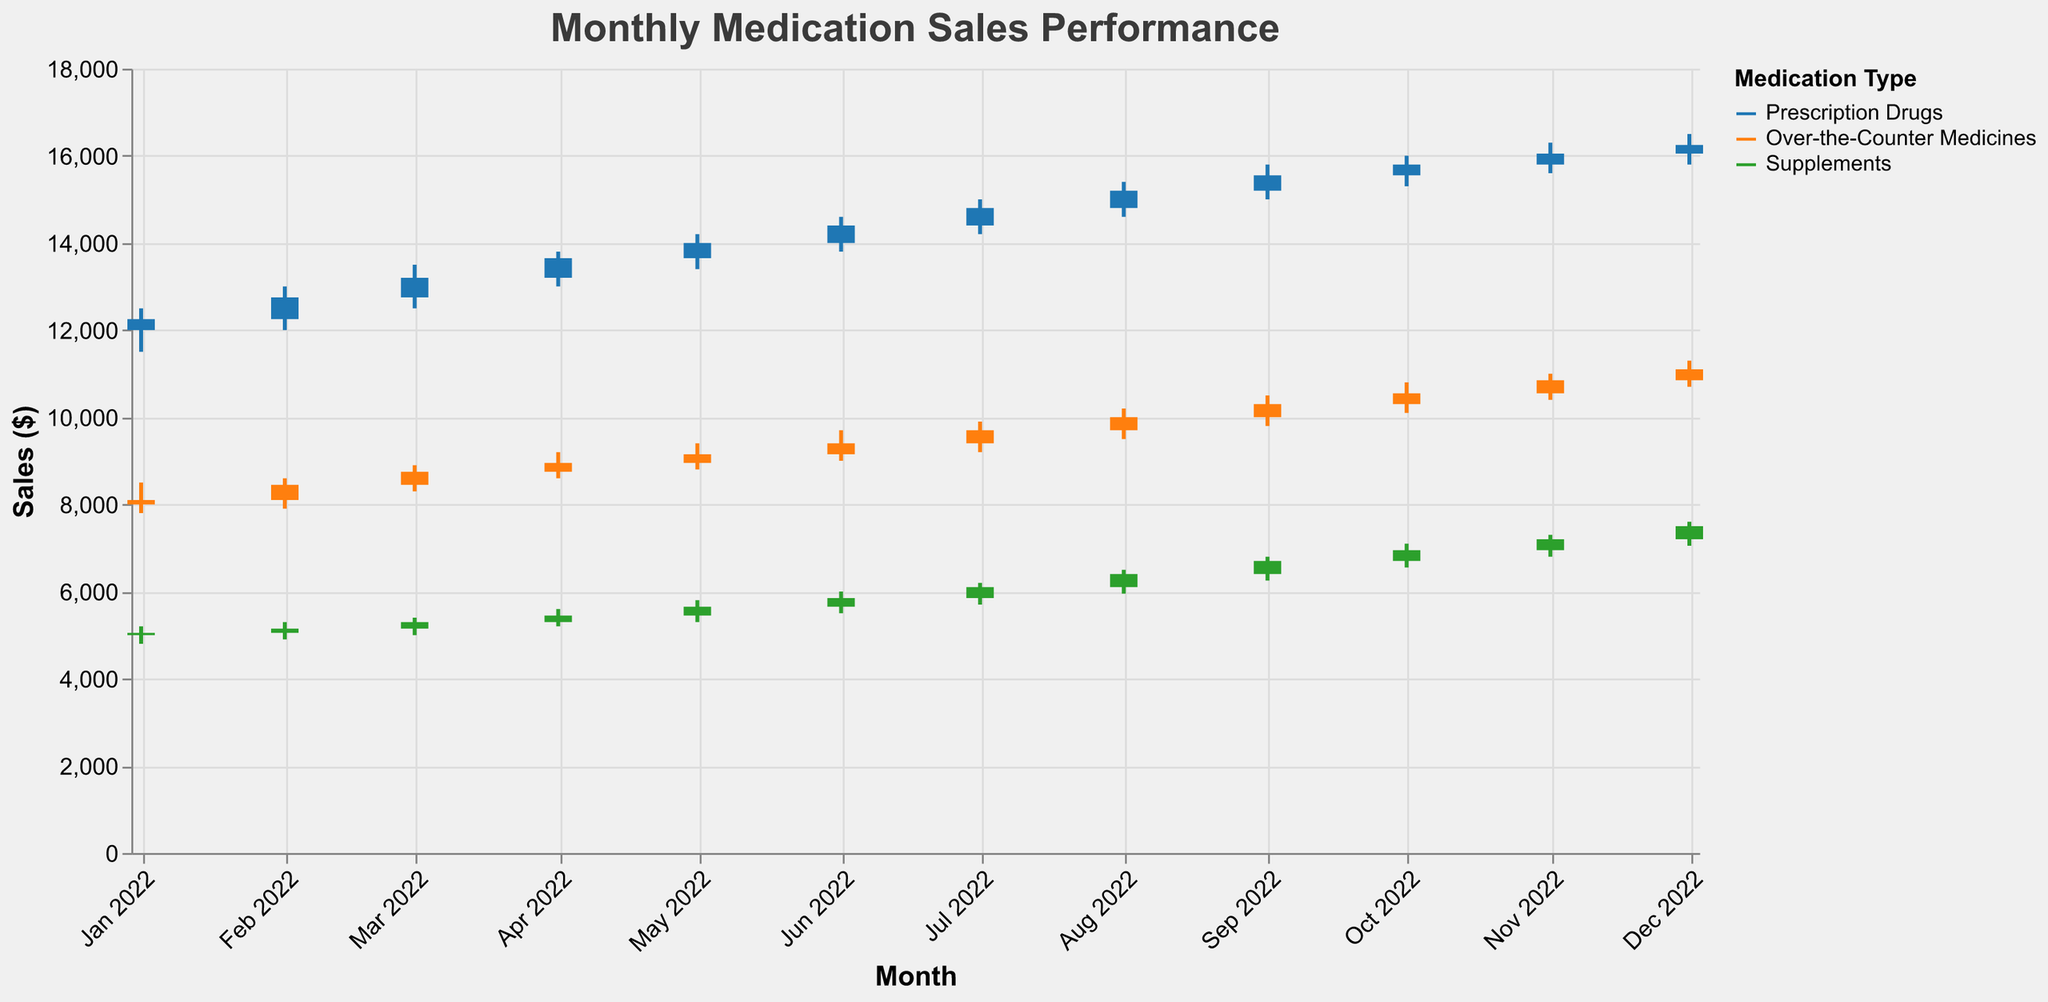What is the title of the figure? The title is typically provided at the top of the chart, clearly indicating the subject of the visualization.
Answer: Monthly Medication Sales Performance Which medication type had the highest sales in December 2022? By looking at the December data, the highest 'High' value among the different medication types is for Prescription Drugs at $16500.
Answer: Prescription Drugs What was the closing sales value for Supplements in May 2022? Find the 'Close' value for Supplements in May, which is given as $5650.
Answer: $5650 How many data points are there for each medication type? There are 12 months, and for each month, there are data points for Prescription Drugs, Over-the-Counter Medicines, and Supplements, making it 12 data points per type.
Answer: 12 Which month had the lowest opening sales value for Over-the-Counter Medicines? The lowest 'Open' value for Over-the-Counter Medicines can be observed by comparing the 'Open' values in each month, which is $8000 in January.
Answer: January 2022 What was the range of sales for Prescription Drugs in July 2022? The range is calculated as the difference between the 'High' and 'Low' values, i.e., $15000 - $14200 = $800.
Answer: $800 Did any medication type experience a decrease in sales from October to November 2022? Compare the 'Close' values for October and November for all medication types. Prescription Drugs increase from $15800 to $16050, Over-the-Counter Medicines increase from $10550 to $10850, and Supplements increase from $6950 to $7200.
Answer: No What is the average high sales value for Supplements in the first quarter of 2022? The first quarter consists of January, February, and March. Add the 'High' values for these months and divide by 3 i.e., $(5200 + 5300 + 5400) / 3 = 5300.
Answer: $5300 What was the sales trend for Prescription Drugs over the year? Observing the 'Close' values for Prescription Drugs from January ($12250) to December ($16250), it shows a general increasing trend.
Answer: Increasing By how much did the sales for Over-the-Counter Medicines increase from February to March 2022? The increase is the difference between the 'Close' values, i.e., $8750 - $8450 = $300.
Answer: $300 